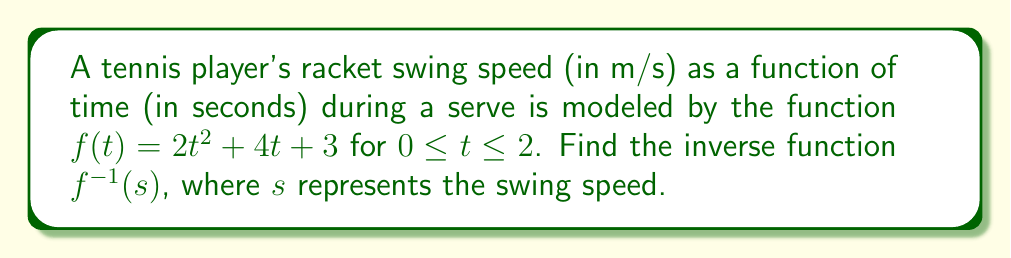Can you solve this math problem? To find the inverse function, we'll follow these steps:

1) Replace $f(t)$ with $s$:
   $s = 2t^2 + 4t + 3$

2) Swap $t$ and $s$:
   $t = 2s^2 + 4s + 3$

3) Solve for $s$:
   $t - 3 = 2s^2 + 4s$
   $t - 3 = 2(s^2 + 2s)$
   $\frac{t - 3}{2} = s^2 + 2s$

4) Complete the square:
   $\frac{t - 3}{2} = (s + 1)^2 - 1$
   $\frac{t - 3}{2} + 1 = (s + 1)^2$
   $\frac{t - 1}{2} = (s + 1)^2$

5) Take the square root of both sides:
   $\pm \sqrt{\frac{t - 1}{2}} = s + 1$

6) Solve for $s$:
   $s = -1 \pm \sqrt{\frac{t - 1}{2}}$

7) Since the original function is increasing (positive coefficient for $t^2$), we choose the positive root:
   $s = -1 + \sqrt{\frac{t - 1}{2}}$

8) Replace $t$ with $s$ for the final inverse function:
   $f^{-1}(s) = -1 + \sqrt{\frac{s - 1}{2}}$
Answer: $f^{-1}(s) = -1 + \sqrt{\frac{s - 1}{2}}$ 